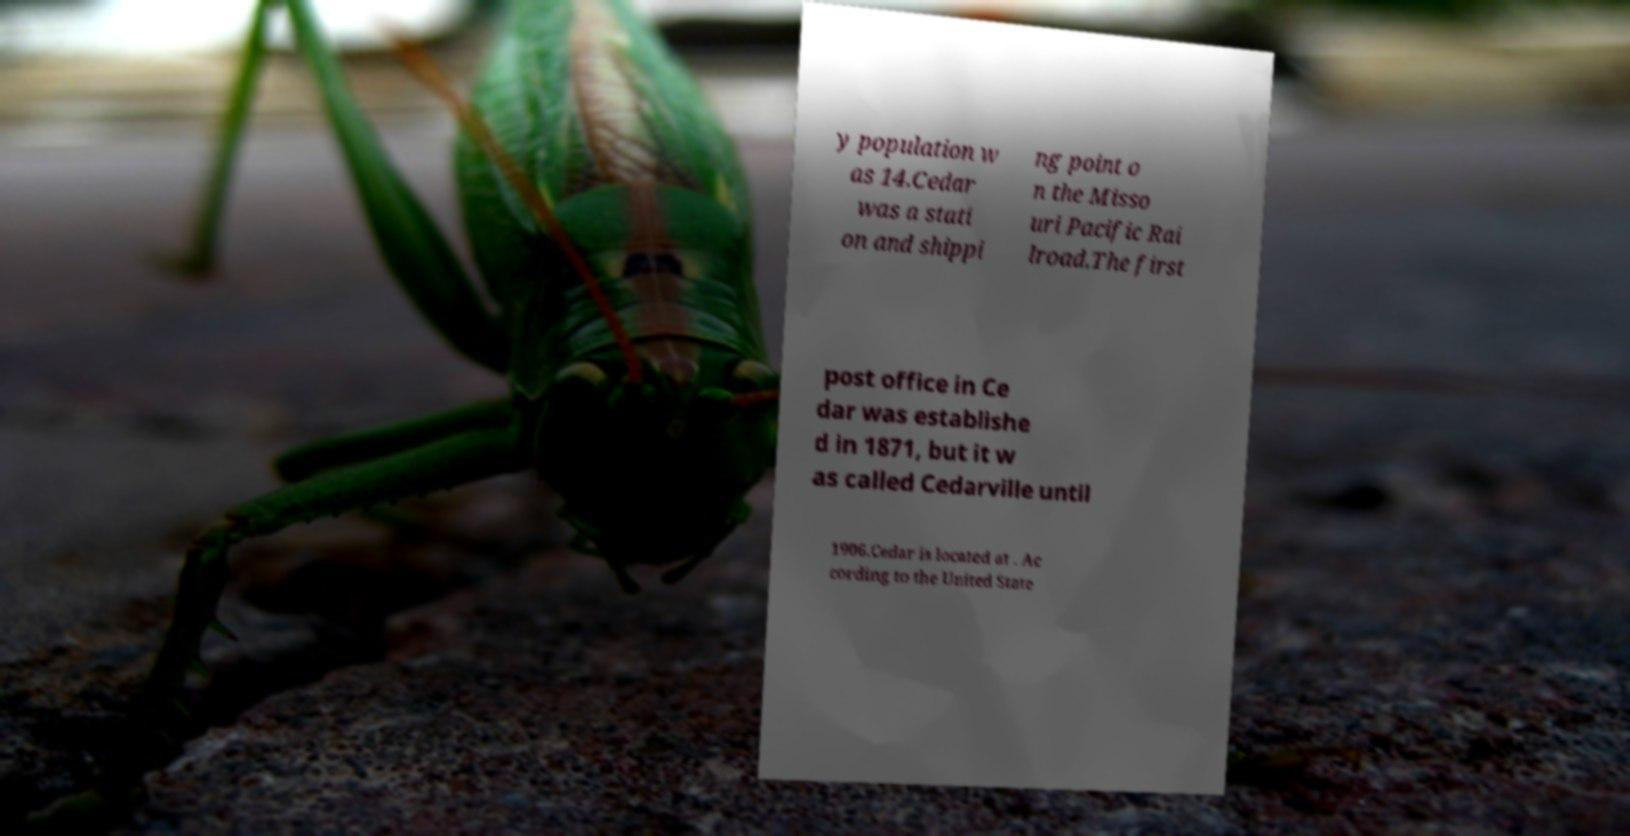Could you extract and type out the text from this image? y population w as 14.Cedar was a stati on and shippi ng point o n the Misso uri Pacific Rai lroad.The first post office in Ce dar was establishe d in 1871, but it w as called Cedarville until 1906.Cedar is located at . Ac cording to the United State 